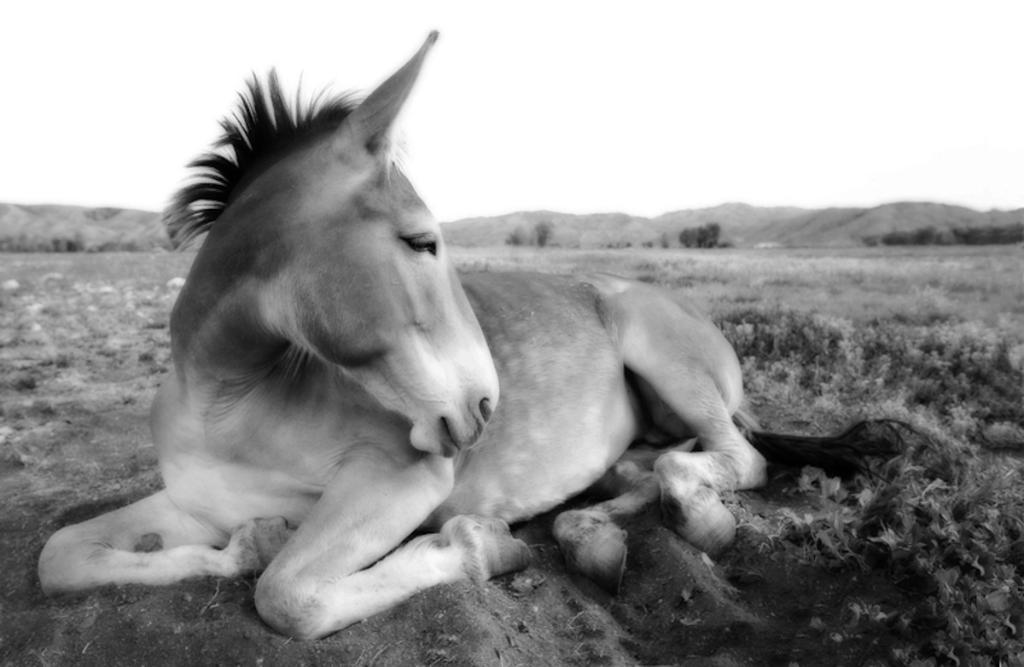What type of animal is in the image? There is an animal in the image, but the specific type cannot be determined from the provided facts. Where is the animal located in the image? The animal is on the ground in the image. What can be seen in the background of the image? There are trees, mountains, and the sky visible in the background of the image. What chance does the aunt have of winning the lottery in the image? There is no mention of an aunt or a lottery in the image, so it is not possible to answer this question. 